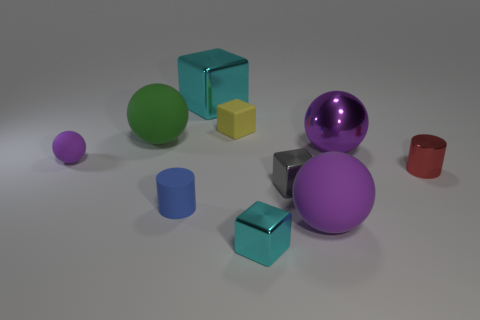Subtract all red blocks. How many purple spheres are left? 3 Subtract all spheres. How many objects are left? 6 Add 2 large cyan cubes. How many large cyan cubes are left? 3 Add 9 tiny blue matte cylinders. How many tiny blue matte cylinders exist? 10 Subtract 1 gray cubes. How many objects are left? 9 Subtract all brown rubber cylinders. Subtract all cyan cubes. How many objects are left? 8 